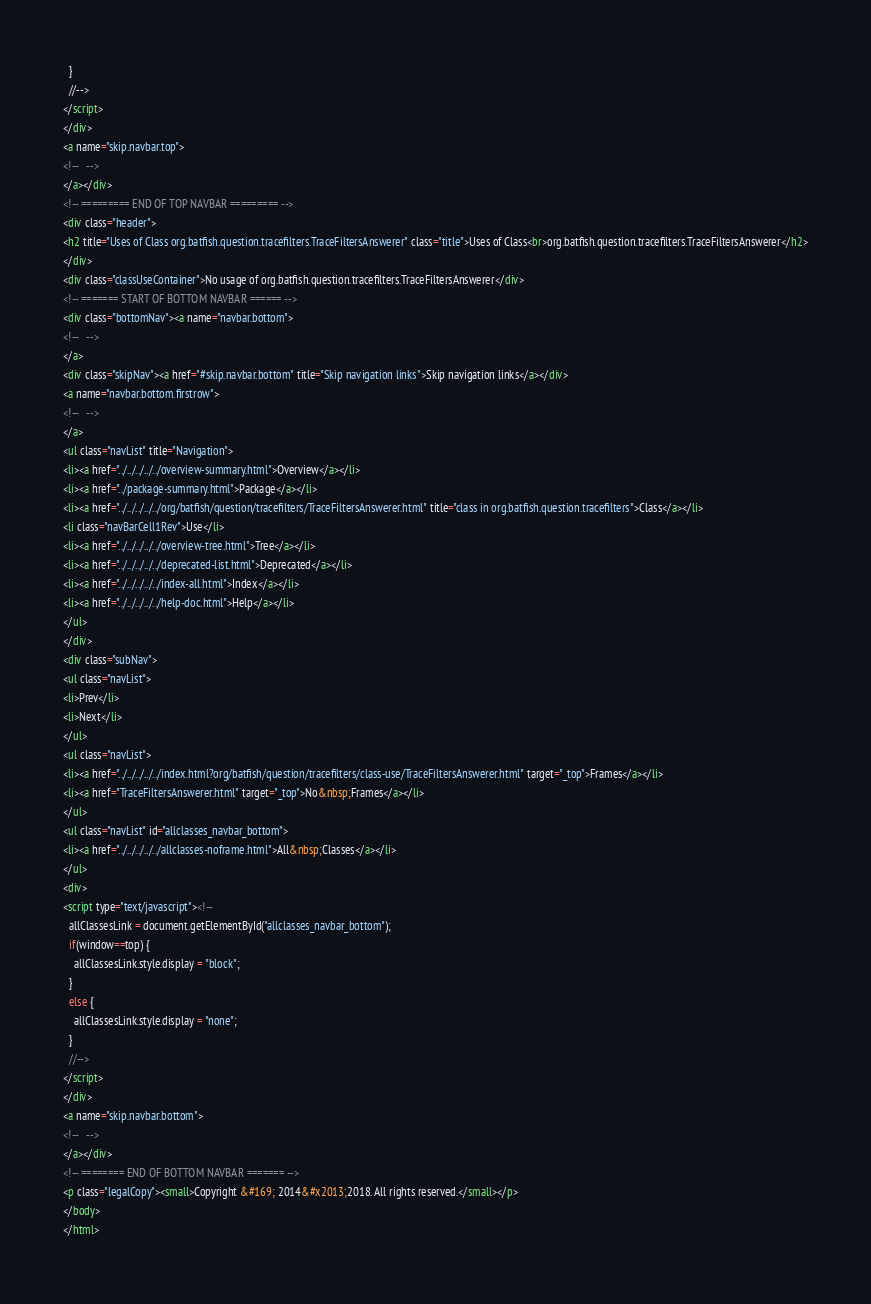<code> <loc_0><loc_0><loc_500><loc_500><_HTML_>  }
  //-->
</script>
</div>
<a name="skip.navbar.top">
<!--   -->
</a></div>
<!-- ========= END OF TOP NAVBAR ========= -->
<div class="header">
<h2 title="Uses of Class org.batfish.question.tracefilters.TraceFiltersAnswerer" class="title">Uses of Class<br>org.batfish.question.tracefilters.TraceFiltersAnswerer</h2>
</div>
<div class="classUseContainer">No usage of org.batfish.question.tracefilters.TraceFiltersAnswerer</div>
<!-- ======= START OF BOTTOM NAVBAR ====== -->
<div class="bottomNav"><a name="navbar.bottom">
<!--   -->
</a>
<div class="skipNav"><a href="#skip.navbar.bottom" title="Skip navigation links">Skip navigation links</a></div>
<a name="navbar.bottom.firstrow">
<!--   -->
</a>
<ul class="navList" title="Navigation">
<li><a href="../../../../../overview-summary.html">Overview</a></li>
<li><a href="../package-summary.html">Package</a></li>
<li><a href="../../../../../org/batfish/question/tracefilters/TraceFiltersAnswerer.html" title="class in org.batfish.question.tracefilters">Class</a></li>
<li class="navBarCell1Rev">Use</li>
<li><a href="../../../../../overview-tree.html">Tree</a></li>
<li><a href="../../../../../deprecated-list.html">Deprecated</a></li>
<li><a href="../../../../../index-all.html">Index</a></li>
<li><a href="../../../../../help-doc.html">Help</a></li>
</ul>
</div>
<div class="subNav">
<ul class="navList">
<li>Prev</li>
<li>Next</li>
</ul>
<ul class="navList">
<li><a href="../../../../../index.html?org/batfish/question/tracefilters/class-use/TraceFiltersAnswerer.html" target="_top">Frames</a></li>
<li><a href="TraceFiltersAnswerer.html" target="_top">No&nbsp;Frames</a></li>
</ul>
<ul class="navList" id="allclasses_navbar_bottom">
<li><a href="../../../../../allclasses-noframe.html">All&nbsp;Classes</a></li>
</ul>
<div>
<script type="text/javascript"><!--
  allClassesLink = document.getElementById("allclasses_navbar_bottom");
  if(window==top) {
    allClassesLink.style.display = "block";
  }
  else {
    allClassesLink.style.display = "none";
  }
  //-->
</script>
</div>
<a name="skip.navbar.bottom">
<!--   -->
</a></div>
<!-- ======== END OF BOTTOM NAVBAR ======= -->
<p class="legalCopy"><small>Copyright &#169; 2014&#x2013;2018. All rights reserved.</small></p>
</body>
</html>
</code> 